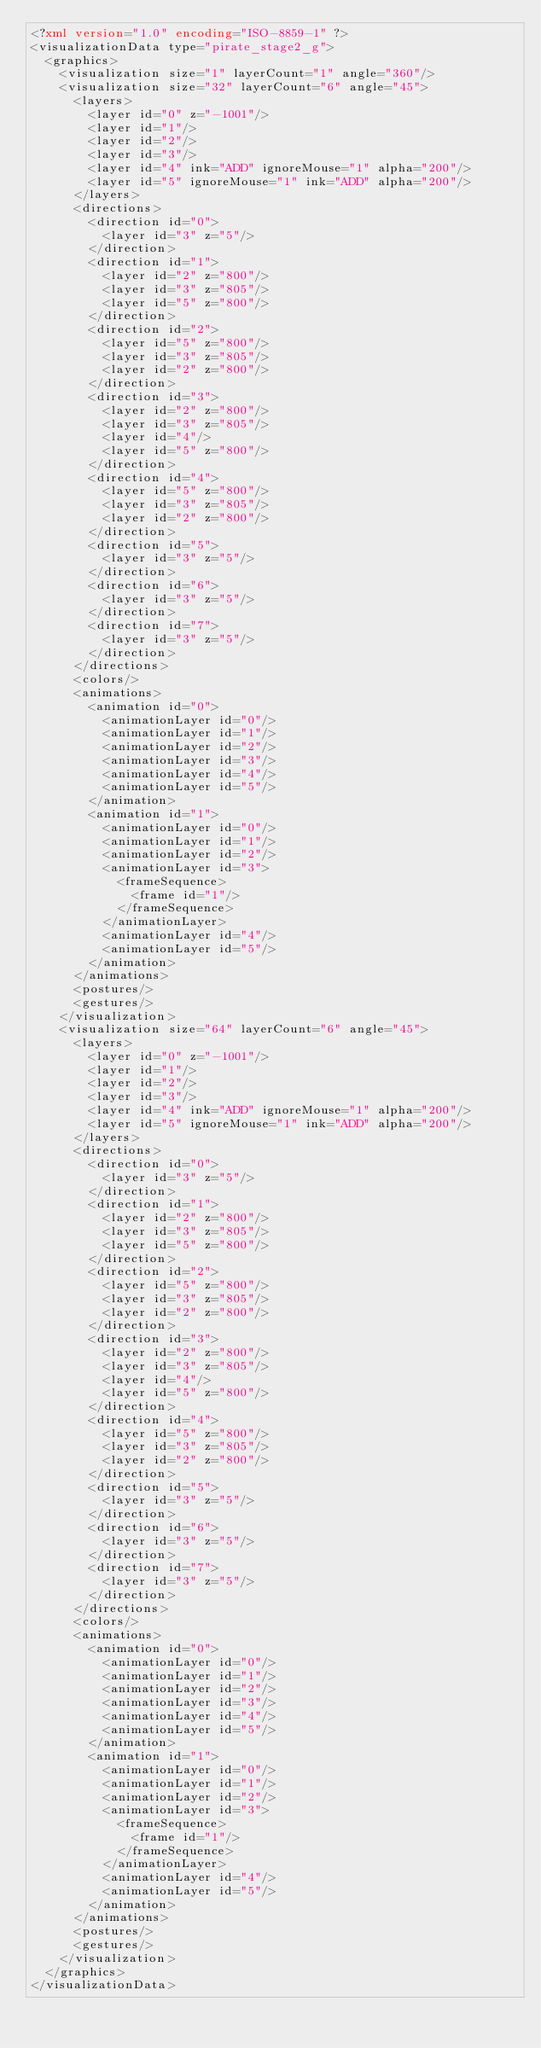Convert code to text. <code><loc_0><loc_0><loc_500><loc_500><_XML_><?xml version="1.0" encoding="ISO-8859-1" ?><visualizationData type="pirate_stage2_g">
  <graphics>
    <visualization size="1" layerCount="1" angle="360"/>
    <visualization size="32" layerCount="6" angle="45">
      <layers>
        <layer id="0" z="-1001"/>
        <layer id="1"/>
        <layer id="2"/>
        <layer id="3"/>
        <layer id="4" ink="ADD" ignoreMouse="1" alpha="200"/>
        <layer id="5" ignoreMouse="1" ink="ADD" alpha="200"/>
      </layers>
      <directions>
        <direction id="0">
          <layer id="3" z="5"/>
        </direction>
        <direction id="1">
          <layer id="2" z="800"/>
          <layer id="3" z="805"/>
          <layer id="5" z="800"/>
        </direction>
        <direction id="2">
          <layer id="5" z="800"/>
          <layer id="3" z="805"/>
          <layer id="2" z="800"/>
        </direction>
        <direction id="3">
          <layer id="2" z="800"/>
          <layer id="3" z="805"/>
          <layer id="4"/>
          <layer id="5" z="800"/>
        </direction>
        <direction id="4">
          <layer id="5" z="800"/>
          <layer id="3" z="805"/>
          <layer id="2" z="800"/>
        </direction>
        <direction id="5">
          <layer id="3" z="5"/>
        </direction>
        <direction id="6">
          <layer id="3" z="5"/>
        </direction>
        <direction id="7">
          <layer id="3" z="5"/>
        </direction>
      </directions>
      <colors/>
      <animations>
        <animation id="0">
          <animationLayer id="0"/>
          <animationLayer id="1"/>
          <animationLayer id="2"/>
          <animationLayer id="3"/>
          <animationLayer id="4"/>
          <animationLayer id="5"/>
        </animation>
        <animation id="1">
          <animationLayer id="0"/>
          <animationLayer id="1"/>
          <animationLayer id="2"/>
          <animationLayer id="3">
            <frameSequence>
              <frame id="1"/>
            </frameSequence>
          </animationLayer>
          <animationLayer id="4"/>
          <animationLayer id="5"/>
        </animation>
      </animations>
      <postures/>
      <gestures/>
    </visualization>
    <visualization size="64" layerCount="6" angle="45">
      <layers>
        <layer id="0" z="-1001"/>
        <layer id="1"/>
        <layer id="2"/>
        <layer id="3"/>
        <layer id="4" ink="ADD" ignoreMouse="1" alpha="200"/>
        <layer id="5" ignoreMouse="1" ink="ADD" alpha="200"/>
      </layers>
      <directions>
        <direction id="0">
          <layer id="3" z="5"/>
        </direction>
        <direction id="1">
          <layer id="2" z="800"/>
          <layer id="3" z="805"/>
          <layer id="5" z="800"/>
        </direction>
        <direction id="2">
          <layer id="5" z="800"/>
          <layer id="3" z="805"/>
          <layer id="2" z="800"/>
        </direction>
        <direction id="3">
          <layer id="2" z="800"/>
          <layer id="3" z="805"/>
          <layer id="4"/>
          <layer id="5" z="800"/>
        </direction>
        <direction id="4">
          <layer id="5" z="800"/>
          <layer id="3" z="805"/>
          <layer id="2" z="800"/>
        </direction>
        <direction id="5">
          <layer id="3" z="5"/>
        </direction>
        <direction id="6">
          <layer id="3" z="5"/>
        </direction>
        <direction id="7">
          <layer id="3" z="5"/>
        </direction>
      </directions>
      <colors/>
      <animations>
        <animation id="0">
          <animationLayer id="0"/>
          <animationLayer id="1"/>
          <animationLayer id="2"/>
          <animationLayer id="3"/>
          <animationLayer id="4"/>
          <animationLayer id="5"/>
        </animation>
        <animation id="1">
          <animationLayer id="0"/>
          <animationLayer id="1"/>
          <animationLayer id="2"/>
          <animationLayer id="3">
            <frameSequence>
              <frame id="1"/>
            </frameSequence>
          </animationLayer>
          <animationLayer id="4"/>
          <animationLayer id="5"/>
        </animation>
      </animations>
      <postures/>
      <gestures/>
    </visualization>
  </graphics>
</visualizationData></code> 